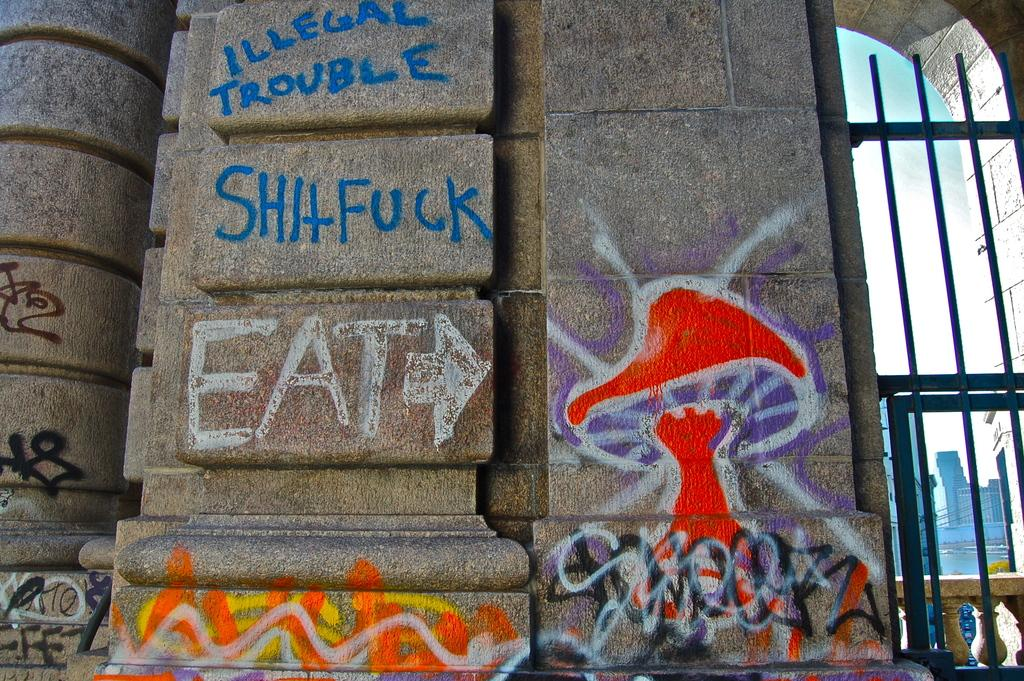What is present on the wall in the image? There are paintings and letters on the wall in the image. What type of structure might be in front of the wall? It appears to be an iron gate in the image. What architectural feature can be seen in the image? There is an arch in the image. What can be seen in the background of the image? There are buildings visible in the background of the image. What type of silk fabric is draped over the arch in the image? There is no silk fabric present in the image; the arch is visible without any fabric draped over it. 